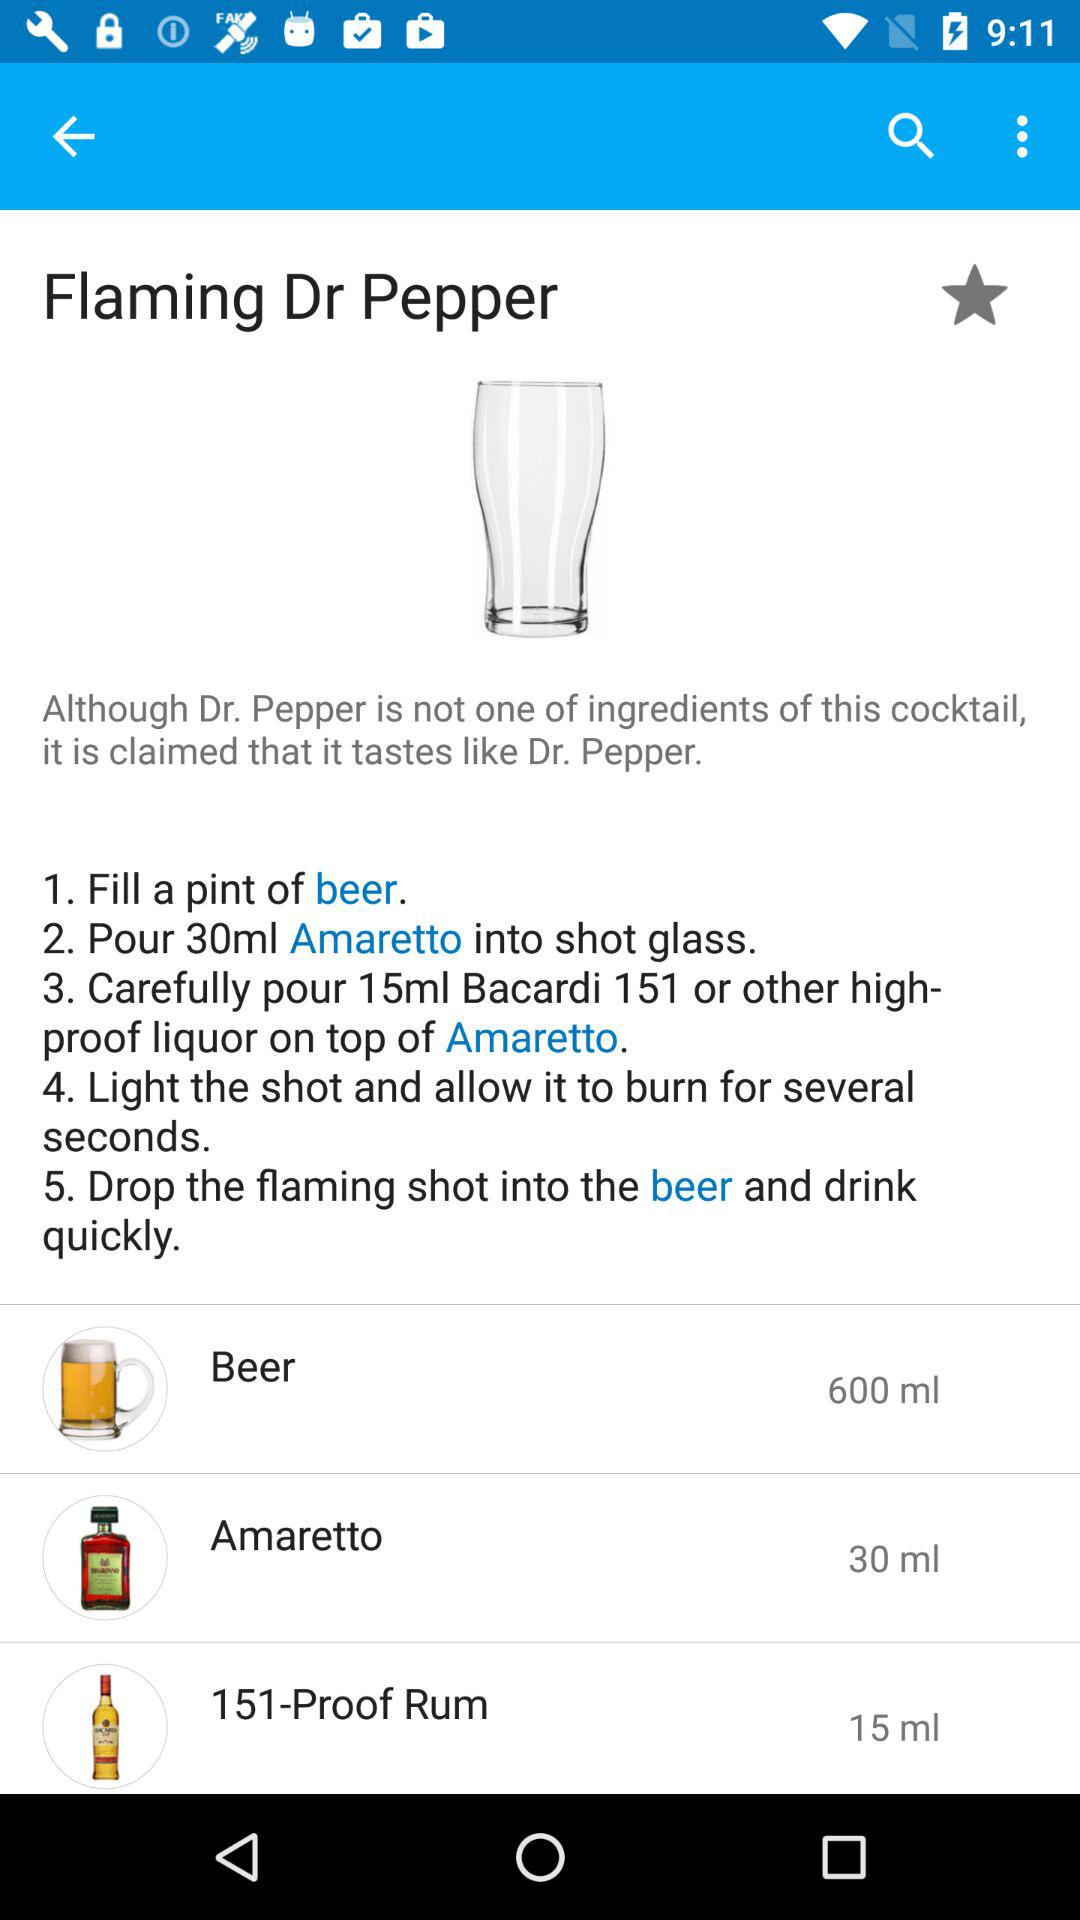In what glass is the 30 ml of amaretto poured? It is poured into a shot glass. 